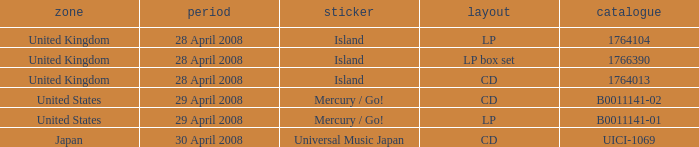What is the Region of the 1766390 Catalog? United Kingdom. 